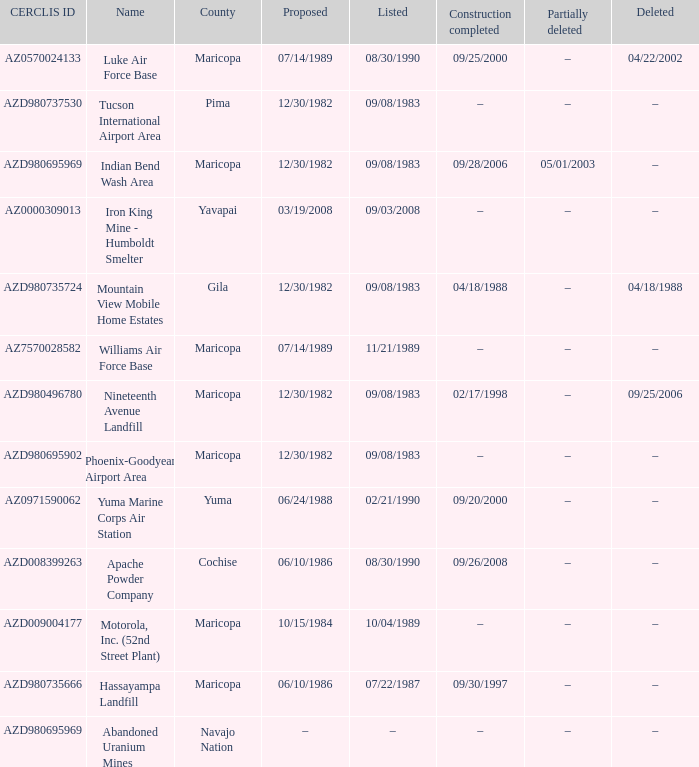Can you give me this table as a dict? {'header': ['CERCLIS ID', 'Name', 'County', 'Proposed', 'Listed', 'Construction completed', 'Partially deleted', 'Deleted'], 'rows': [['AZ0570024133', 'Luke Air Force Base', 'Maricopa', '07/14/1989', '08/30/1990', '09/25/2000', '–', '04/22/2002'], ['AZD980737530', 'Tucson International Airport Area', 'Pima', '12/30/1982', '09/08/1983', '–', '–', '–'], ['AZD980695969', 'Indian Bend Wash Area', 'Maricopa', '12/30/1982', '09/08/1983', '09/28/2006', '05/01/2003', '–'], ['AZ0000309013', 'Iron King Mine - Humboldt Smelter', 'Yavapai', '03/19/2008', '09/03/2008', '–', '–', '–'], ['AZD980735724', 'Mountain View Mobile Home Estates', 'Gila', '12/30/1982', '09/08/1983', '04/18/1988', '–', '04/18/1988'], ['AZ7570028582', 'Williams Air Force Base', 'Maricopa', '07/14/1989', '11/21/1989', '–', '–', '–'], ['AZD980496780', 'Nineteenth Avenue Landfill', 'Maricopa', '12/30/1982', '09/08/1983', '02/17/1998', '–', '09/25/2006'], ['AZD980695902', 'Phoenix-Goodyear Airport Area', 'Maricopa', '12/30/1982', '09/08/1983', '–', '–', '–'], ['AZ0971590062', 'Yuma Marine Corps Air Station', 'Yuma', '06/24/1988', '02/21/1990', '09/20/2000', '–', '–'], ['AZD008399263', 'Apache Powder Company', 'Cochise', '06/10/1986', '08/30/1990', '09/26/2008', '–', '–'], ['AZD009004177', 'Motorola, Inc. (52nd Street Plant)', 'Maricopa', '10/15/1984', '10/04/1989', '–', '–', '–'], ['AZD980735666', 'Hassayampa Landfill', 'Maricopa', '06/10/1986', '07/22/1987', '09/30/1997', '–', '–'], ['AZD980695969', 'Abandoned Uranium Mines', 'Navajo Nation', '–', '–', '–', '–', '–']]} When was the site listed when the county is cochise? 08/30/1990. 